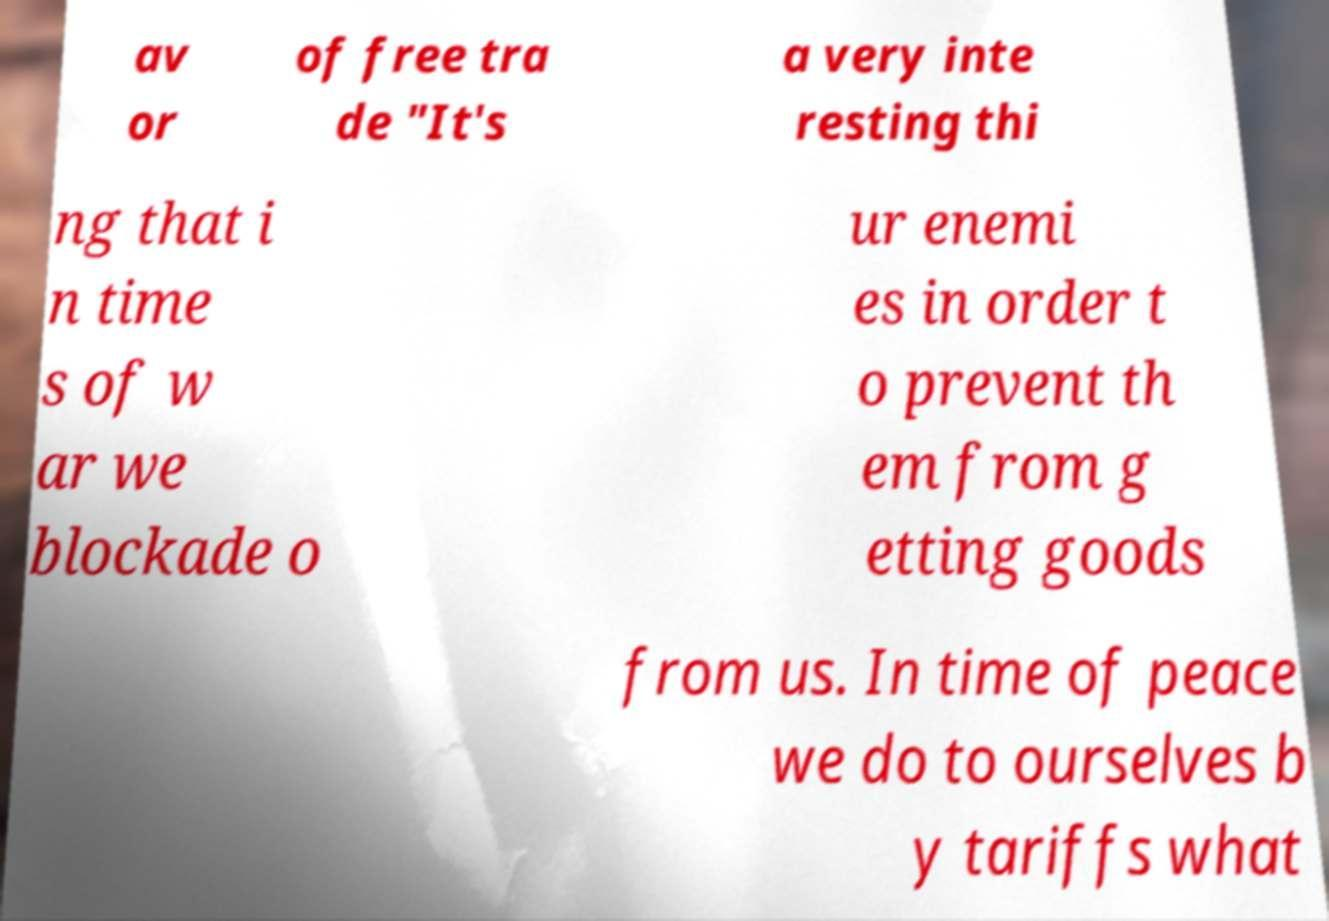I need the written content from this picture converted into text. Can you do that? av or of free tra de "It's a very inte resting thi ng that i n time s of w ar we blockade o ur enemi es in order t o prevent th em from g etting goods from us. In time of peace we do to ourselves b y tariffs what 